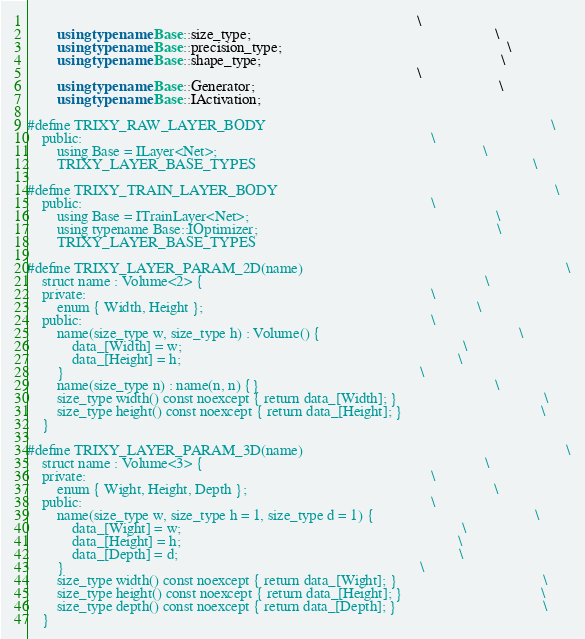Convert code to text. <code><loc_0><loc_0><loc_500><loc_500><_C++_>                                                                                                        \
        using typename Base::size_type;                                                                 \
        using typename Base::precision_type;                                                            \
        using typename Base::shape_type;                                                                \
                                                                                                        \
        using typename Base::Generator;                                                                 \
        using typename Base::IActivation;

#define TRIXY_RAW_LAYER_BODY                                                                            \
    public:                                                                                             \
        using Base = ILayer<Net>;                                                                       \
        TRIXY_LAYER_BASE_TYPES                                                                          \

#define TRIXY_TRAIN_LAYER_BODY                                                                          \
    public:                                                                                             \
        using Base = ITrainLayer<Net>;                                                                  \
        using typename Base::IOptimizer;                                                                \
        TRIXY_LAYER_BASE_TYPES

#define TRIXY_LAYER_PARAM_2D(name)                                                                      \
    struct name : Volume<2> {                                                                           \
    private:                                                                                            \
        enum { Width, Height };                                                                         \
    public:                                                                                             \
        name(size_type w, size_type h) : Volume() {                                                     \
            data_[Width] = w;                                                                           \
            data_[Height] = h;                                                                          \
        }                                                                                               \
        name(size_type n) : name(n, n) {}                                                               \
        size_type width() const noexcept { return data_[Width]; }                                       \
        size_type height() const noexcept { return data_[Height]; }                                     \
    }

#define TRIXY_LAYER_PARAM_3D(name)                                                                      \
    struct name : Volume<3> {                                                                           \
    private:                                                                                            \
        enum { Wight, Height, Depth };                                                                  \
    public:                                                                                             \
        name(size_type w, size_type h = 1, size_type d = 1) {                                           \
            data_[Wight] = w;                                                                           \
            data_[Height] = h;                                                                          \
            data_[Depth] = d;                                                                           \
        }                                                                                               \
        size_type width() const noexcept { return data_[Wight]; }                                       \
        size_type height() const noexcept { return data_[Height]; }                                     \
        size_type depth() const noexcept { return data_[Depth]; }                                       \
    }
</code> 